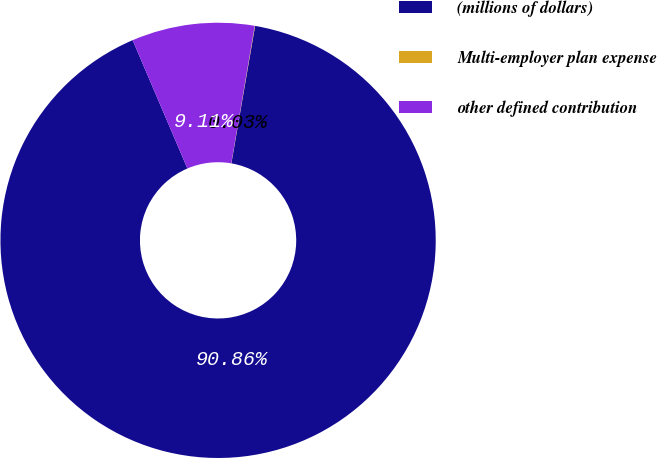<chart> <loc_0><loc_0><loc_500><loc_500><pie_chart><fcel>(millions of dollars)<fcel>Multi-employer plan expense<fcel>other defined contribution<nl><fcel>90.86%<fcel>0.03%<fcel>9.11%<nl></chart> 